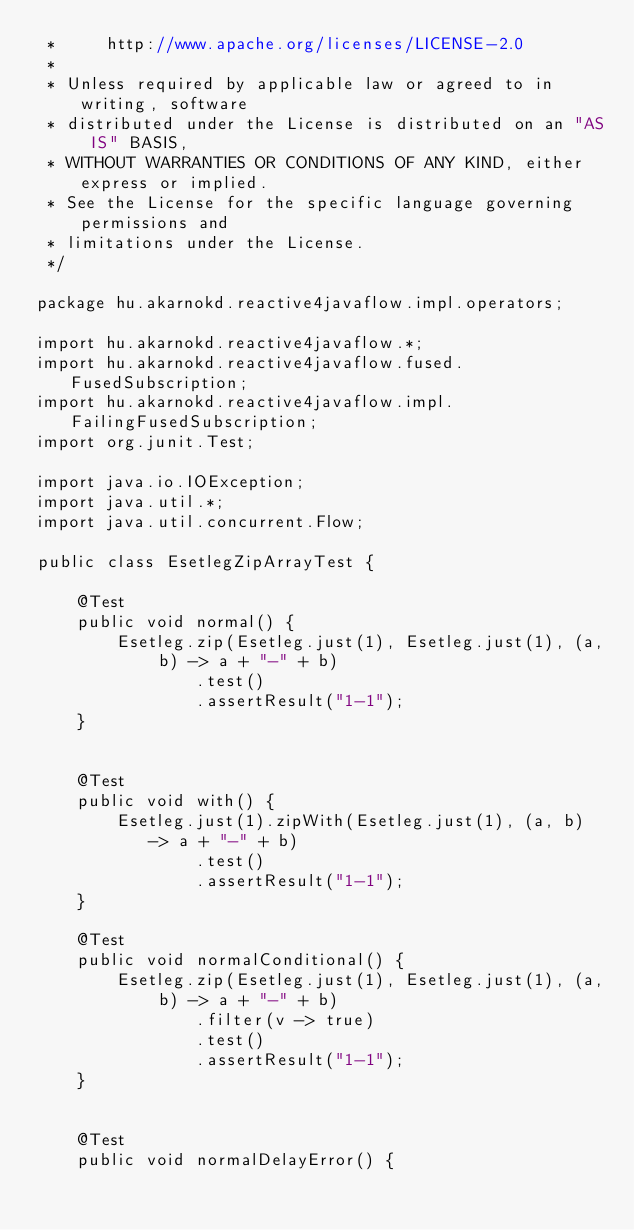Convert code to text. <code><loc_0><loc_0><loc_500><loc_500><_Java_> *     http://www.apache.org/licenses/LICENSE-2.0
 *
 * Unless required by applicable law or agreed to in writing, software
 * distributed under the License is distributed on an "AS IS" BASIS,
 * WITHOUT WARRANTIES OR CONDITIONS OF ANY KIND, either express or implied.
 * See the License for the specific language governing permissions and
 * limitations under the License.
 */

package hu.akarnokd.reactive4javaflow.impl.operators;

import hu.akarnokd.reactive4javaflow.*;
import hu.akarnokd.reactive4javaflow.fused.FusedSubscription;
import hu.akarnokd.reactive4javaflow.impl.FailingFusedSubscription;
import org.junit.Test;

import java.io.IOException;
import java.util.*;
import java.util.concurrent.Flow;

public class EsetlegZipArrayTest {

    @Test
    public void normal() {
        Esetleg.zip(Esetleg.just(1), Esetleg.just(1), (a, b) -> a + "-" + b)
                .test()
                .assertResult("1-1");
    }


    @Test
    public void with() {
        Esetleg.just(1).zipWith(Esetleg.just(1), (a, b) -> a + "-" + b)
                .test()
                .assertResult("1-1");
    }

    @Test
    public void normalConditional() {
        Esetleg.zip(Esetleg.just(1), Esetleg.just(1), (a, b) -> a + "-" + b)
                .filter(v -> true)
                .test()
                .assertResult("1-1");
    }


    @Test
    public void normalDelayError() {</code> 